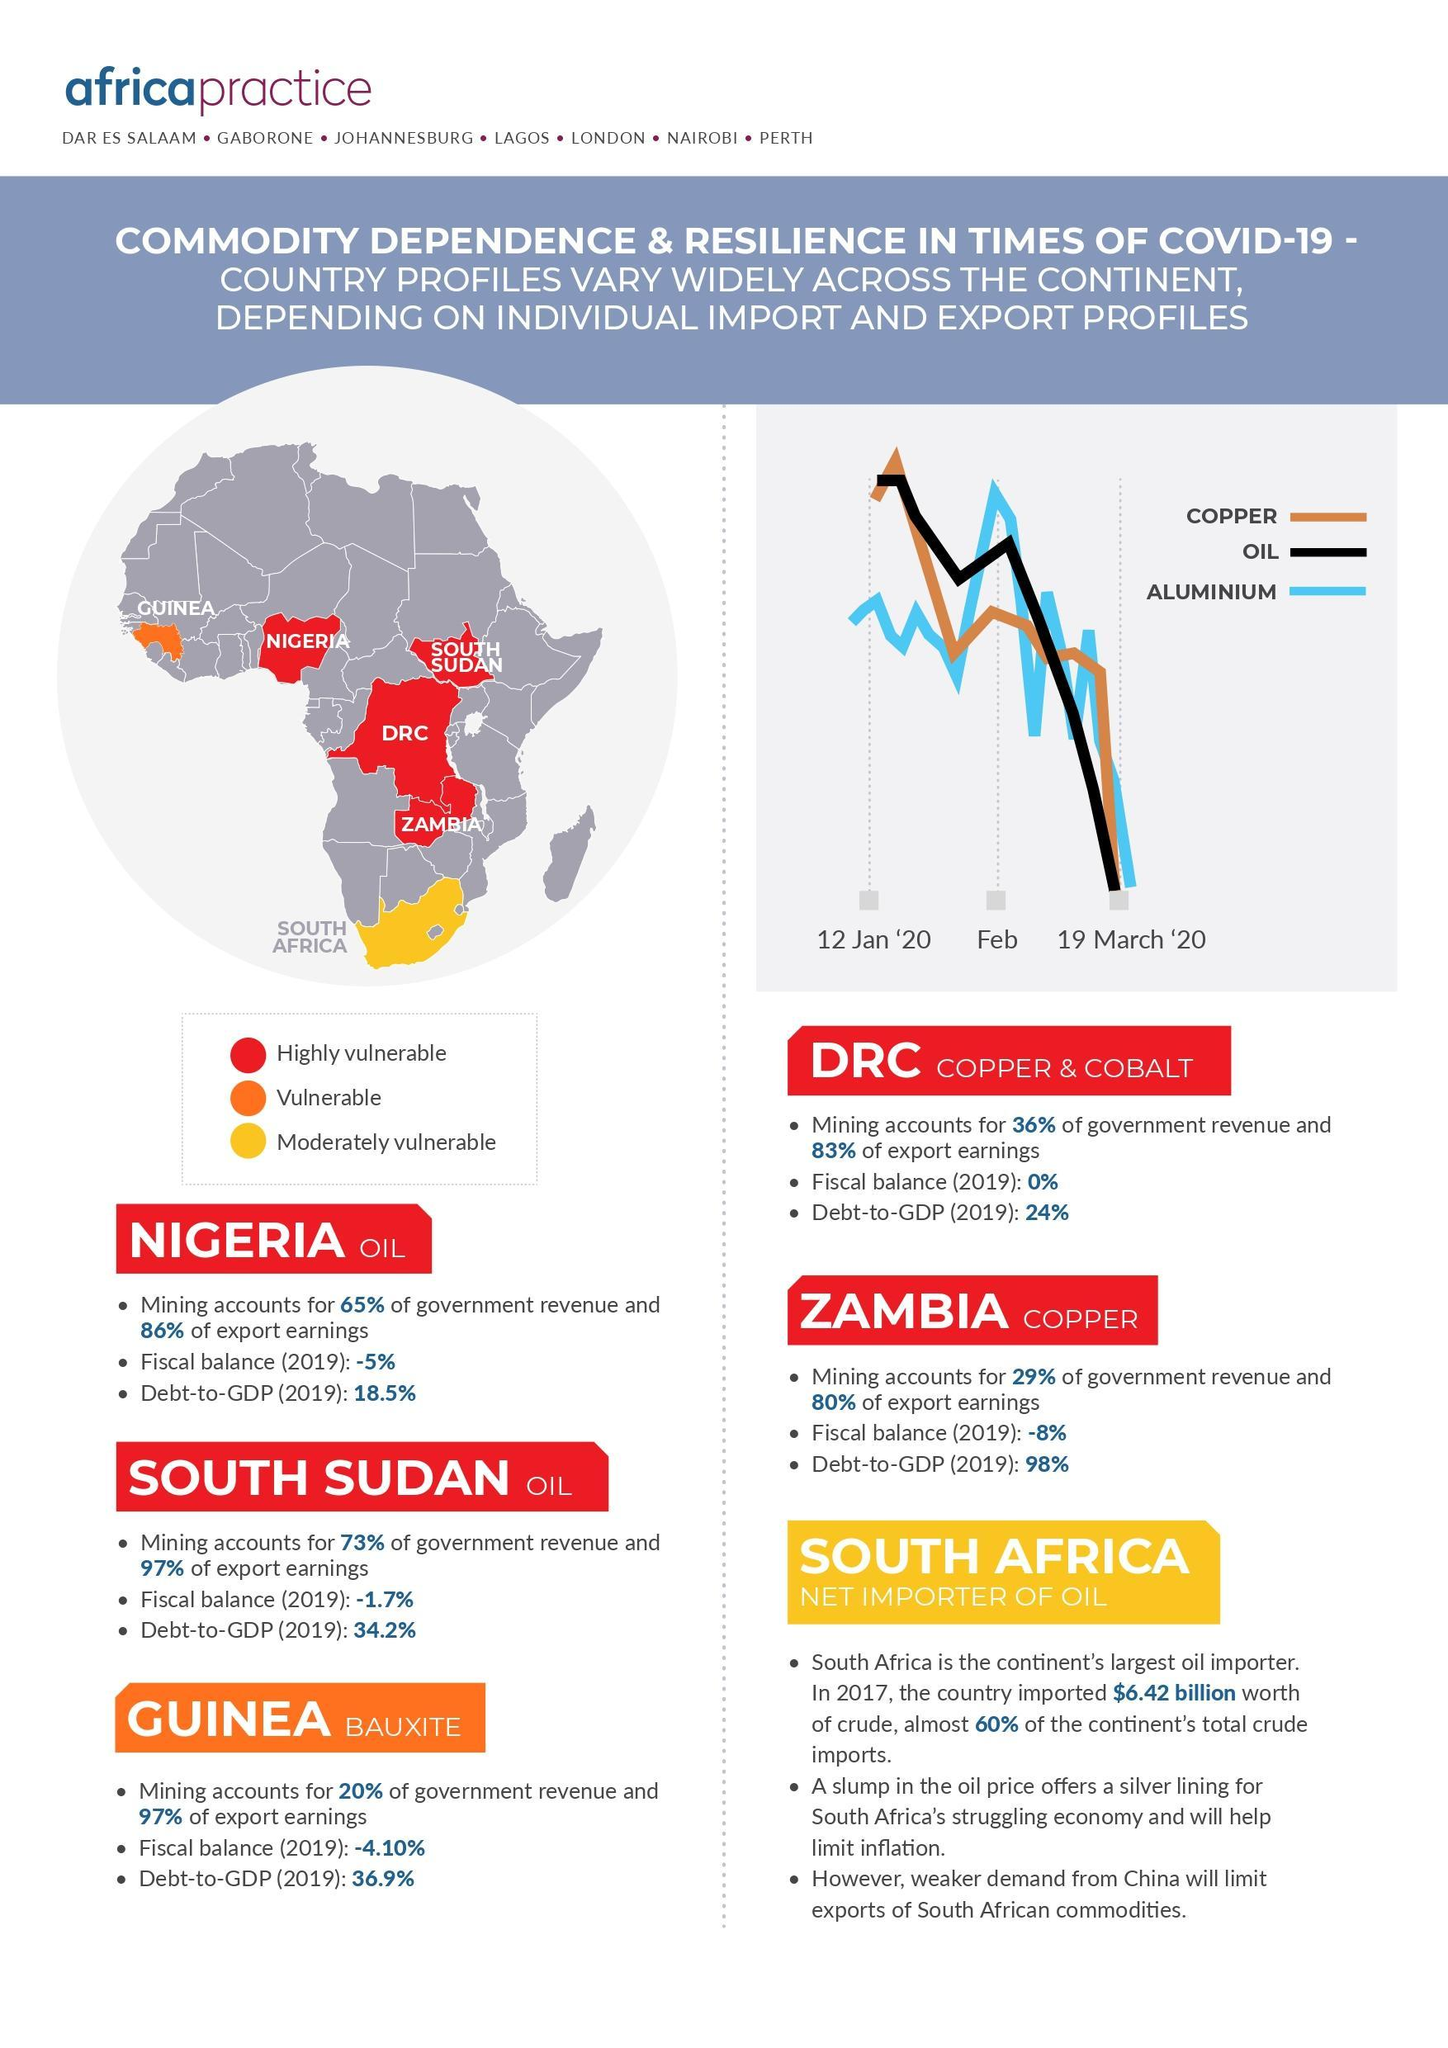What are the three commodities plotted on the graph?
Answer the question with a short phrase. Copper, Oil, Aluminium Which is the southernmost country of Africa? South Africa What does Guinea export? Bauxite Which country's economy will benefit from a decrease in the price of oil? South Africa Which is the moderately vulnerable country in Africa? South Africa Which is the country that imports oil? South Africa What does DRC export? Copper & Cobalt Which country has a fiscal balance of 0% (2019)? DRC What are the 3 categories into which the countries are divided based on commodity dependence and resilience? Highly vulnerable, vulnerable, moderately vulnerable How many countries are categorised as vulnerable? 1 How many countries are 'moderately vulnerable'? 1 What is Nigeria's debt-to-GDP (2019)? 18.5% How many countries are 'highly vulnerable'? 4 Which of the West African countries is categorised as vulnerable? Guinea What is the fiscal balance of Guinea (2019)? -4.10% What percent of export earnings does Guinea's bauxite mining account for? 97% Which of the 'oil exporting' countries brings in a higher government revenue? South Sudan Which are the two countries exporting oil? Nigeria, South Sudan Which country is categorised as vulnerable? Guinea Name the two copper exporting countries? DRC, Zambia 